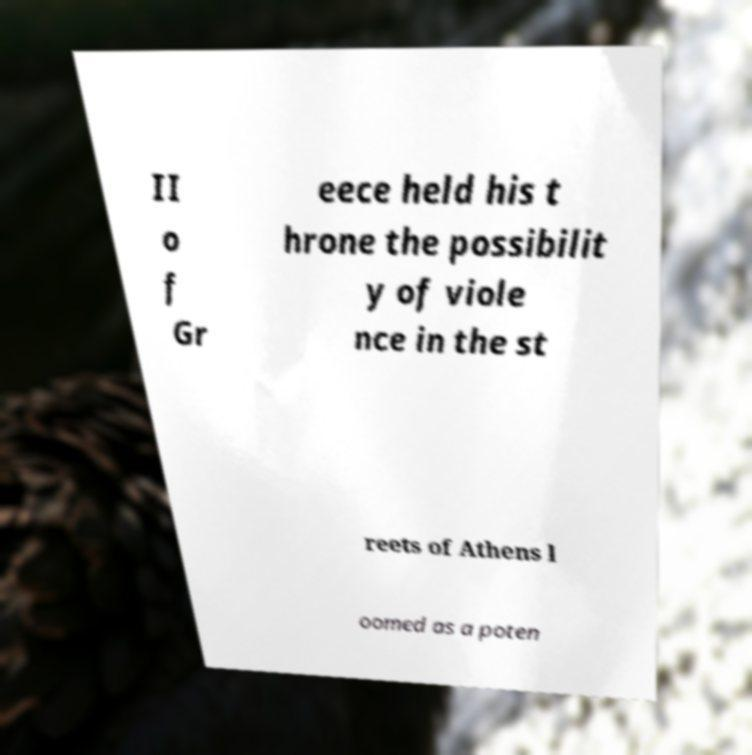Can you accurately transcribe the text from the provided image for me? II o f Gr eece held his t hrone the possibilit y of viole nce in the st reets of Athens l oomed as a poten 